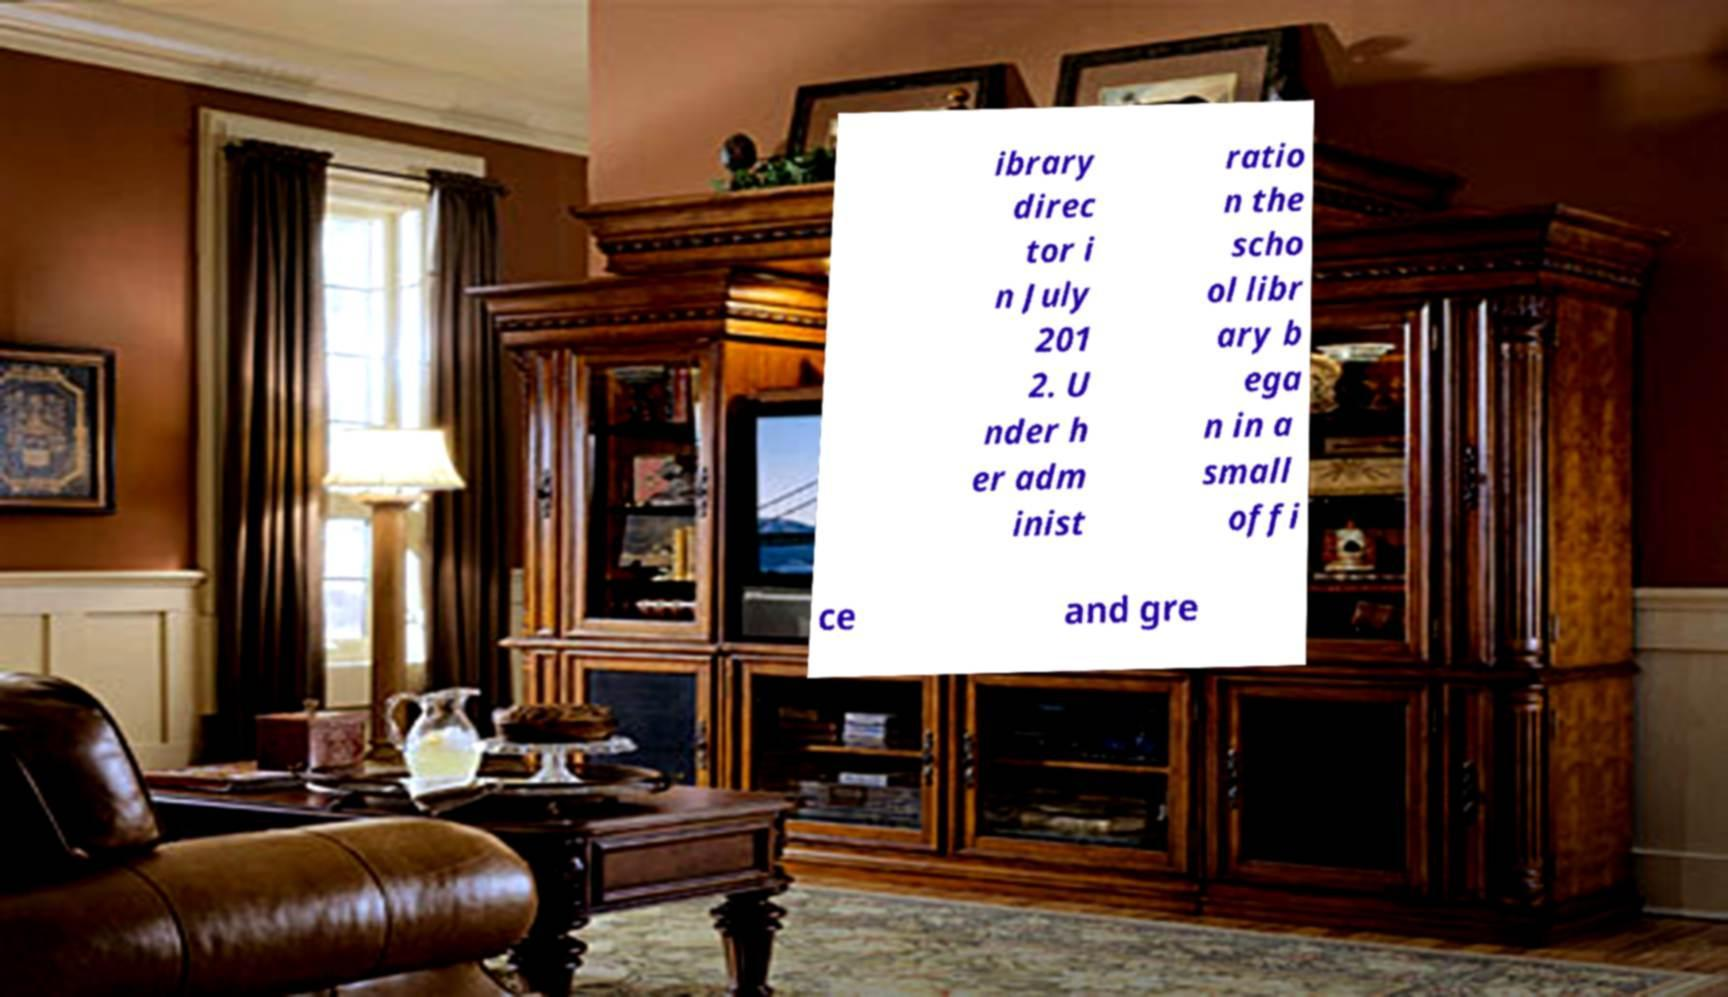What messages or text are displayed in this image? I need them in a readable, typed format. ibrary direc tor i n July 201 2. U nder h er adm inist ratio n the scho ol libr ary b ega n in a small offi ce and gre 